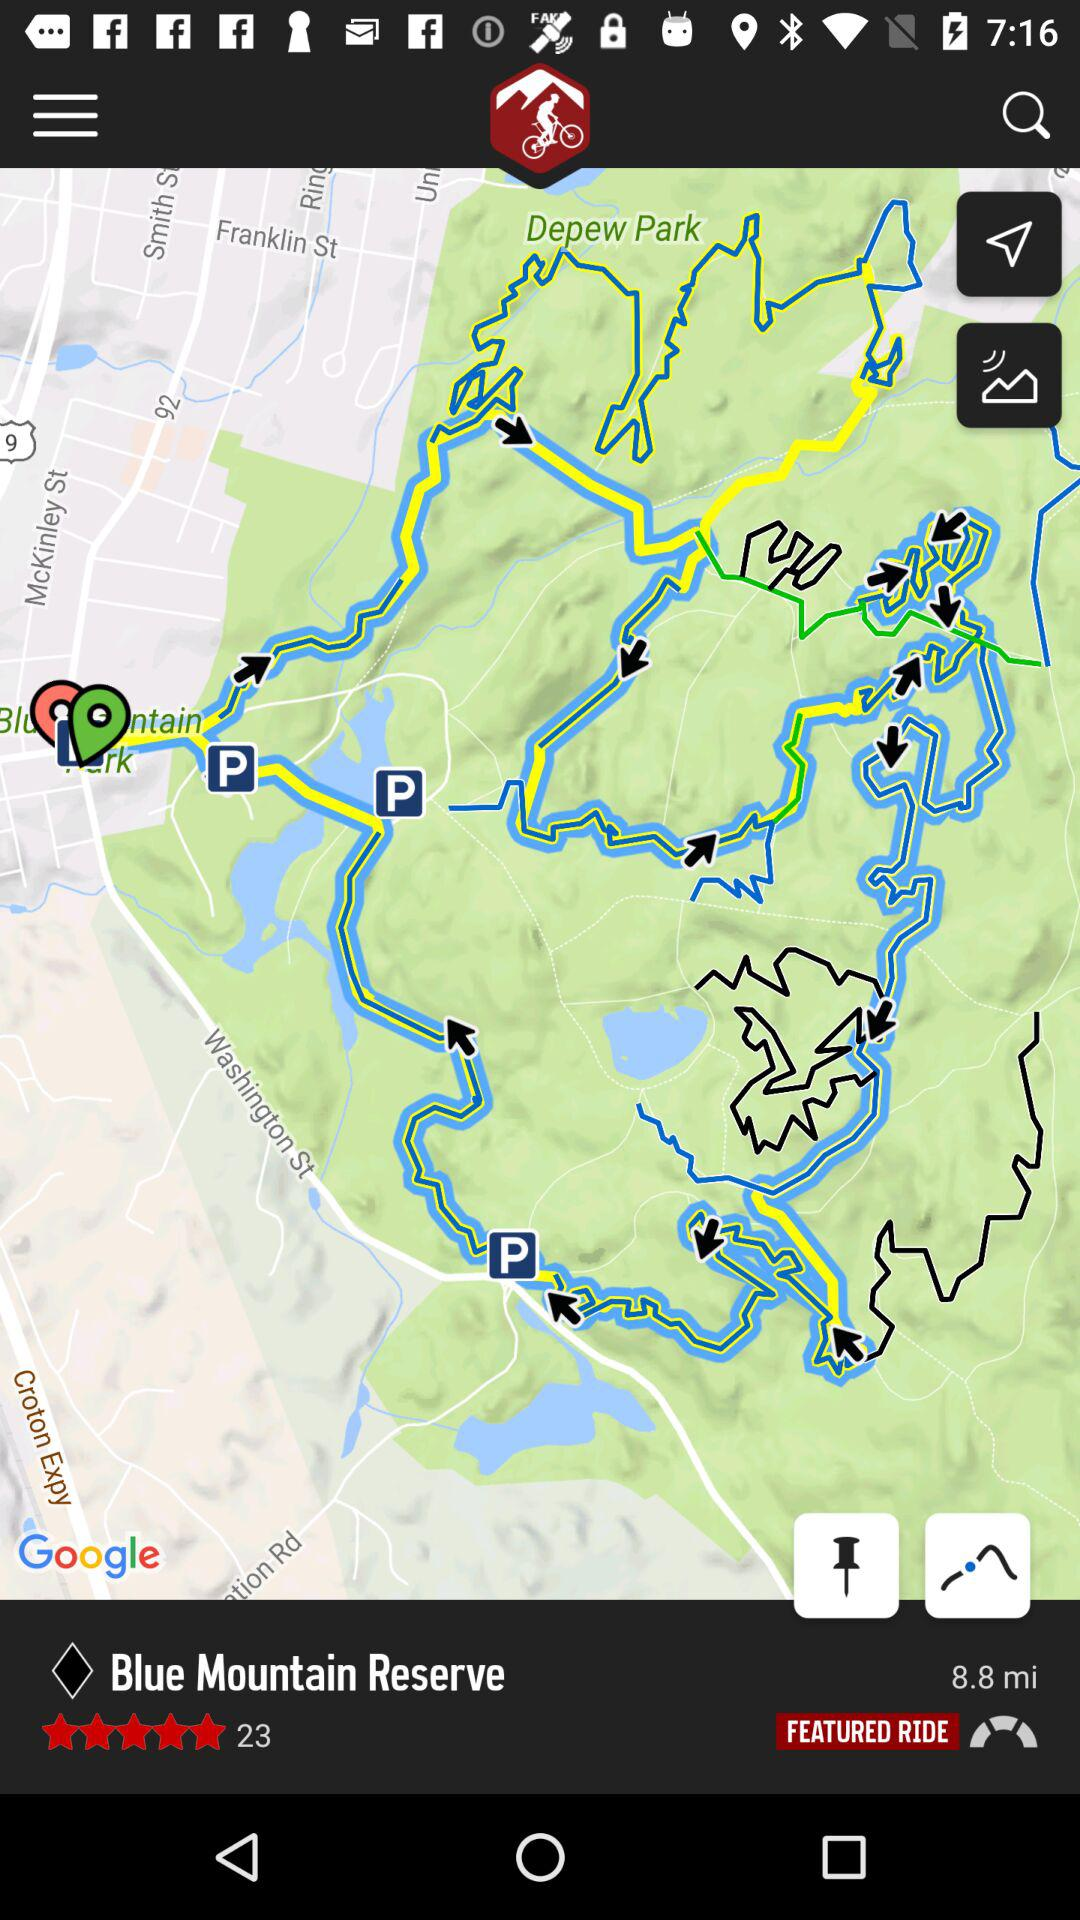How many stars did "Blue Mountain Reserve" get? "Blue Mountain Reserve" got 5 stars. 